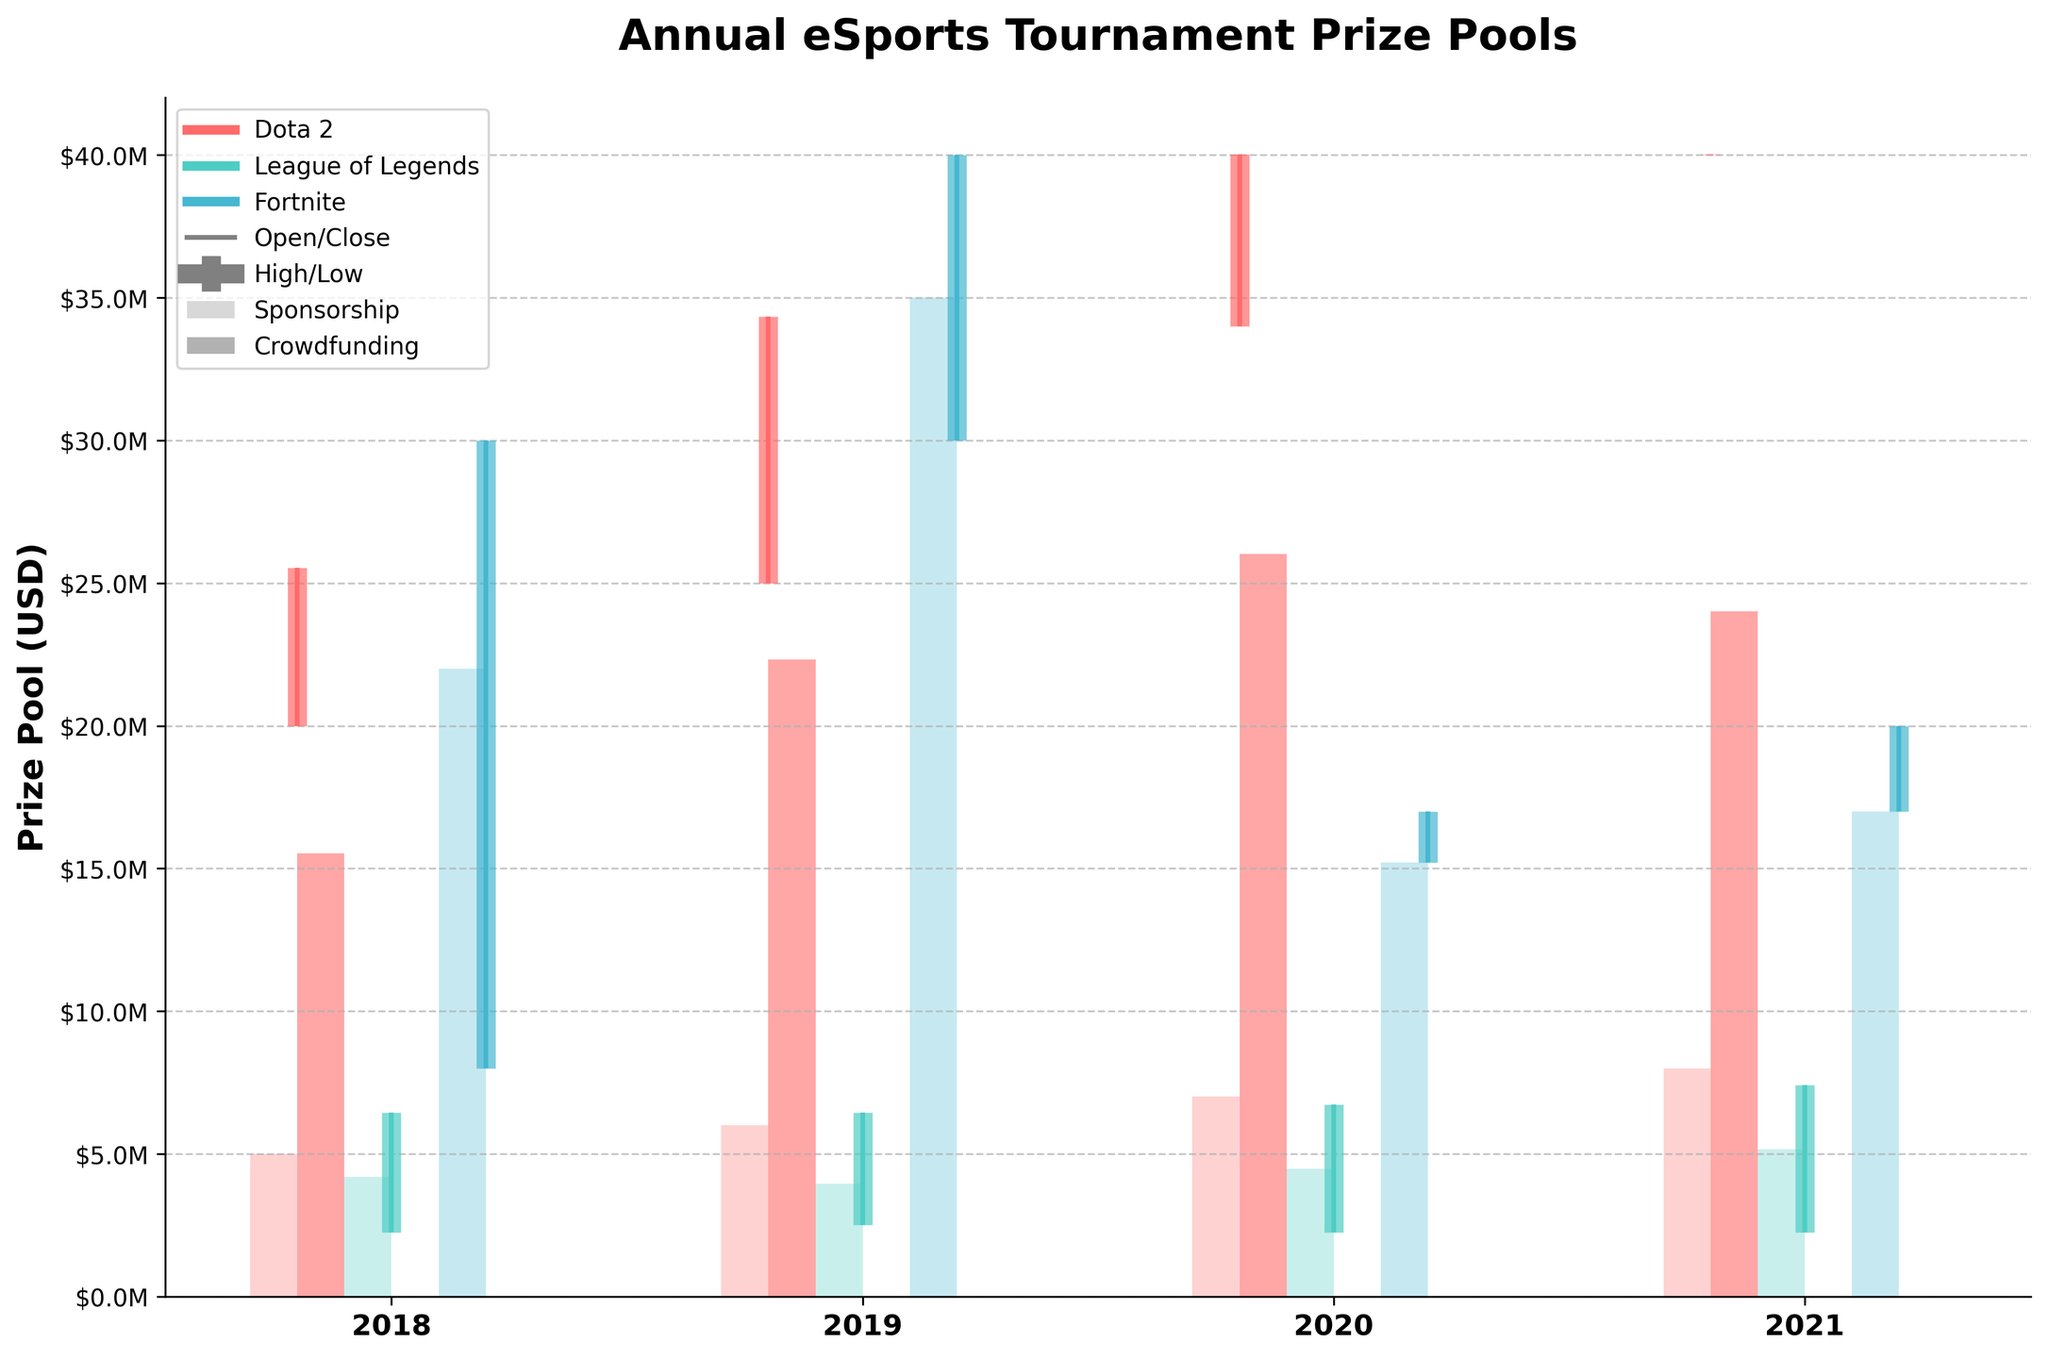How many game titles are compared in the figure? The figure shows distinct lines and bars for different game titles. By counting the unique legends associated with each game, we can determine the number of game titles.
Answer: 3 Which game had the highest prize pool in 2020? To find this, we look at the highest point (High value) of the bars in 2020 for all games. Among Dota 2, League of Legends, and Fortnite, Dota 2 had the highest bar at $40M.
Answer: Dota 2 Between 2018 and 2020, which game exhibited the largest increase in prize pool? Calculate the difference between the 2020 High and the 2018 High for each game: Dota 2: $40.02M - $25.53M = $14.49M, League of Legends: $6.73M - $6.45M = $0.28M, Fortnite: $17M - $30M = -$13M. Dota 2 had the largest increase.
Answer: Dota 2 What was the total sponsorship contribution for all games in 2021? Add the sponsorship values for each game in 2021: Dota 2: $8M, League of Legends: $5.16M, Fortnite: $17M. Total is $8M + $5.16M + $17M = $30.16M.
Answer: $30.16M Which game showed the most consistency in prize pool amounts from Open to Close? Consistency can be judged by the difference between Open and Close. League of Legends had the same values: $2.25M in 2018, 2019, and 2020, and only a slight increase in 2021 to $2.25M to $7.41M; thus, it showed the most consistency.
Answer: League of Legends In 2019, did Fortnite have more sponsorship or crowdfunding contribution? Look at the bars for Fortnite in 2019. Sponsorship is $35M, and there is no crowdfunding bar shown, so sponsorship is greater.
Answer: Sponsorship Compare the Close prize pools of Dota 2 and Fortnite in 2021. Which is higher? The Close value for Dota 2 in 2021 is $40.02M, while Fortnite's Close value is $17M. Therefore, Dota 2 is higher.
Answer: Dota 2 Was there any year where League of Legends saw an increase in both High and Low values compared to the previous year? Analyze the High and Low values for League of Legends year by year. High: $6.45M in 2018, $6.45M in 2019, $6.73M in 2020, $7.41M in 2021. Low: $2.25M in 2018, $2.25M in 2019, $2.25M in 2020, $2.25M in 2021. All years either remain the same or show an increase.
Answer: No For which game is the crowdfunding contribution the highest in 2020? Compare the height of the crowdfunding bars for each game in 2020. Dota 2 has $26.02M, League of Legends and Fortnite have $0. Dota 2 has the highest crowdfunding contribution in 2020.
Answer: Dota 2 Did Dota 2 ever surpass Fortnite's High value in any year? Compare the High values for Dota 2 and Fortnite each year: 2018: No, 2019: No, 2020: No, 2021: Yes ($40.02M vs $20M). Dota 2 surpassed Fortnite's High value in 2021 only.
Answer: 2021 